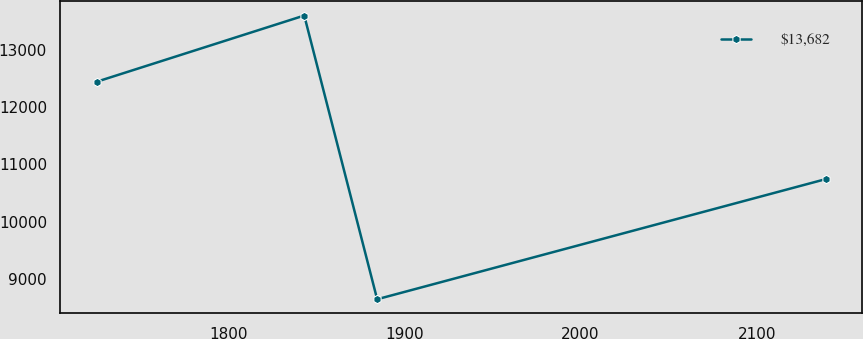Convert chart to OTSL. <chart><loc_0><loc_0><loc_500><loc_500><line_chart><ecel><fcel>$13,682<nl><fcel>1725.26<fcel>12448.9<nl><fcel>1843.14<fcel>13608.9<nl><fcel>1884.53<fcel>8639.17<nl><fcel>2139.15<fcel>10742.9<nl></chart> 